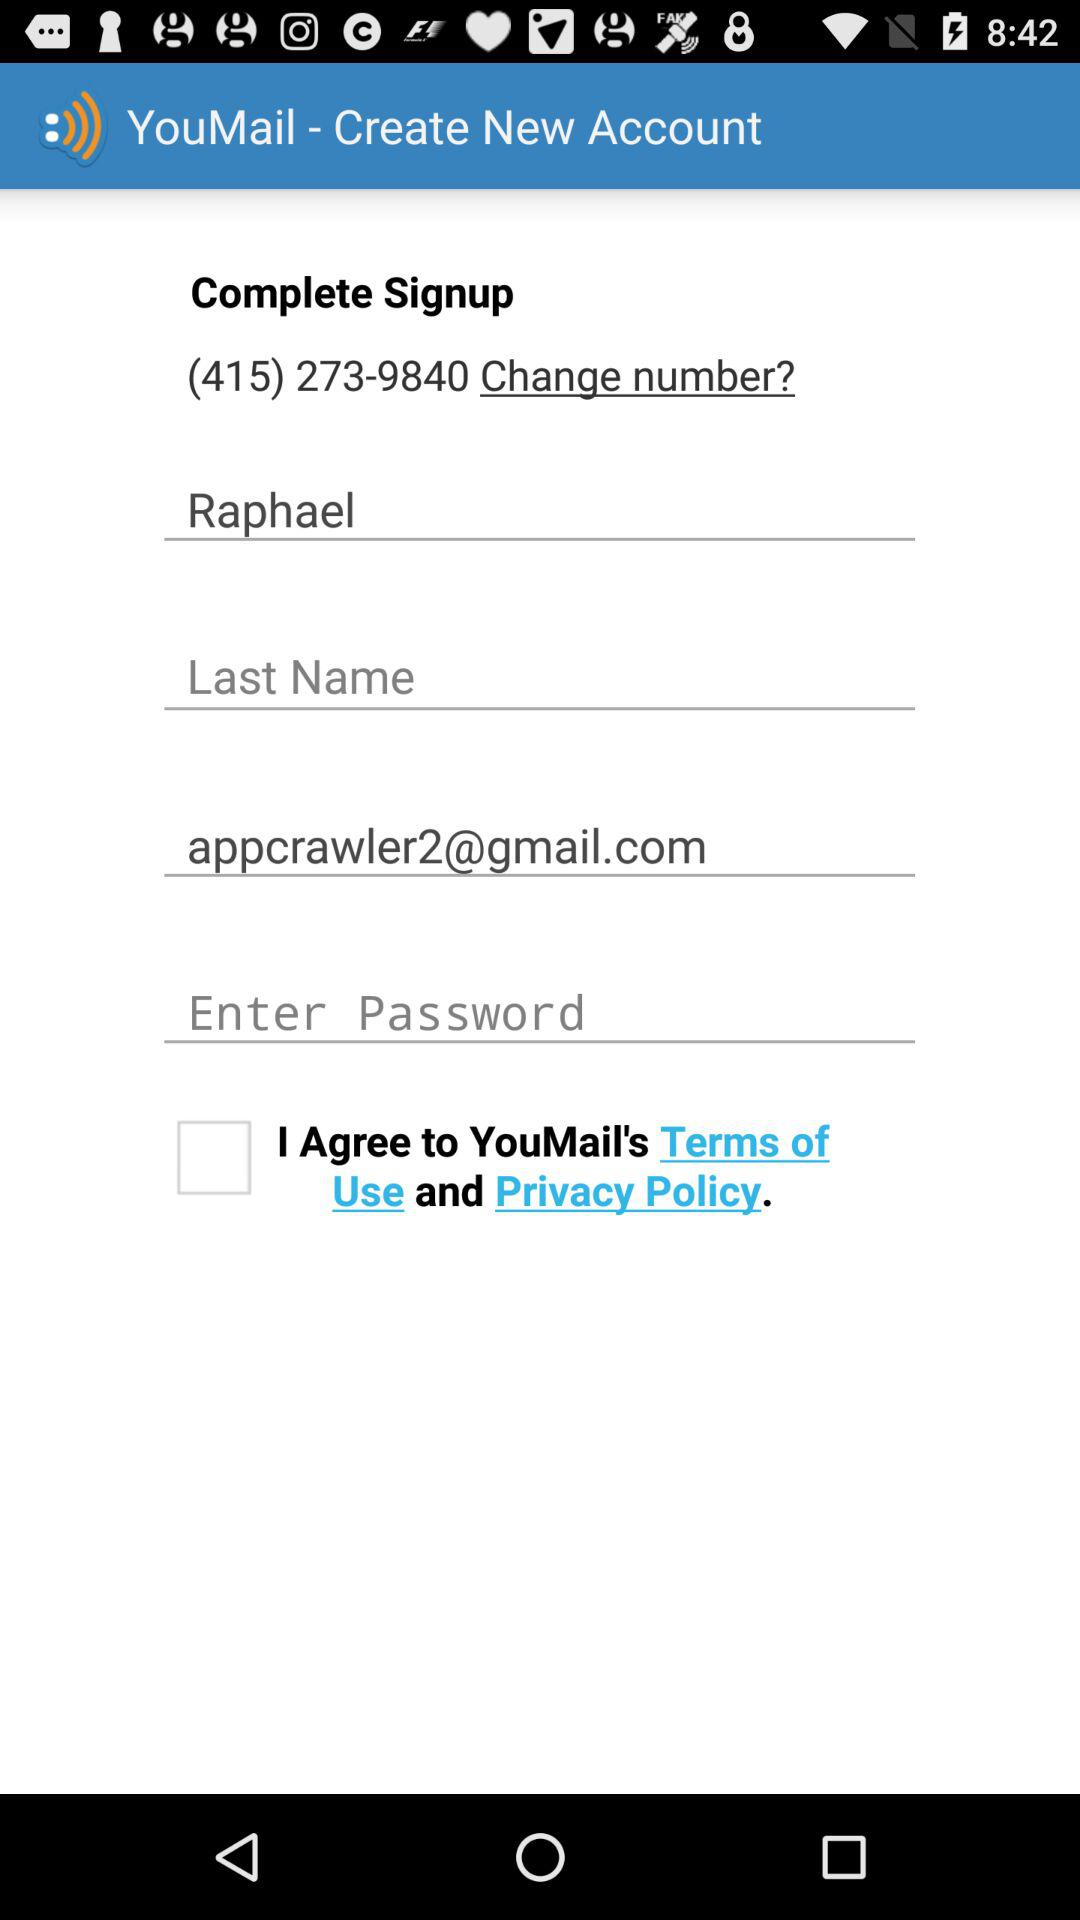How many text fields are there on the sign up form?
Answer the question using a single word or phrase. 4 